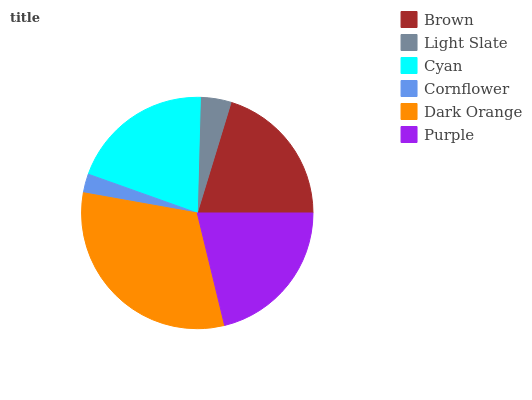Is Cornflower the minimum?
Answer yes or no. Yes. Is Dark Orange the maximum?
Answer yes or no. Yes. Is Light Slate the minimum?
Answer yes or no. No. Is Light Slate the maximum?
Answer yes or no. No. Is Brown greater than Light Slate?
Answer yes or no. Yes. Is Light Slate less than Brown?
Answer yes or no. Yes. Is Light Slate greater than Brown?
Answer yes or no. No. Is Brown less than Light Slate?
Answer yes or no. No. Is Brown the high median?
Answer yes or no. Yes. Is Cyan the low median?
Answer yes or no. Yes. Is Dark Orange the high median?
Answer yes or no. No. Is Cornflower the low median?
Answer yes or no. No. 